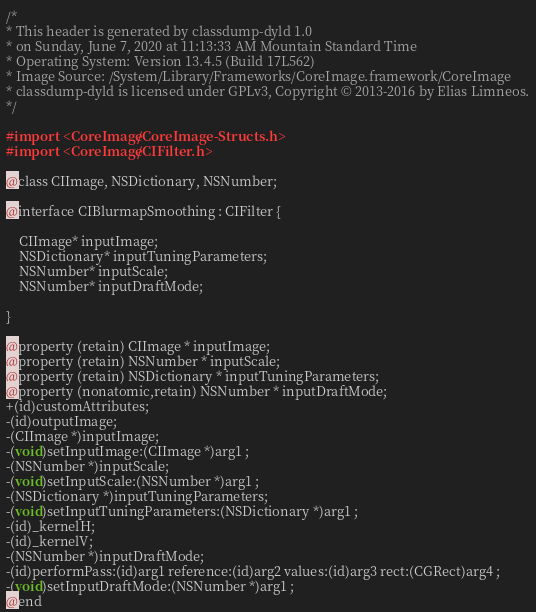Convert code to text. <code><loc_0><loc_0><loc_500><loc_500><_C_>/*
* This header is generated by classdump-dyld 1.0
* on Sunday, June 7, 2020 at 11:13:33 AM Mountain Standard Time
* Operating System: Version 13.4.5 (Build 17L562)
* Image Source: /System/Library/Frameworks/CoreImage.framework/CoreImage
* classdump-dyld is licensed under GPLv3, Copyright © 2013-2016 by Elias Limneos.
*/

#import <CoreImage/CoreImage-Structs.h>
#import <CoreImage/CIFilter.h>

@class CIImage, NSDictionary, NSNumber;

@interface CIBlurmapSmoothing : CIFilter {

	CIImage* inputImage;
	NSDictionary* inputTuningParameters;
	NSNumber* inputScale;
	NSNumber* inputDraftMode;

}

@property (retain) CIImage * inputImage; 
@property (retain) NSNumber * inputScale; 
@property (retain) NSDictionary * inputTuningParameters; 
@property (nonatomic,retain) NSNumber * inputDraftMode; 
+(id)customAttributes;
-(id)outputImage;
-(CIImage *)inputImage;
-(void)setInputImage:(CIImage *)arg1 ;
-(NSNumber *)inputScale;
-(void)setInputScale:(NSNumber *)arg1 ;
-(NSDictionary *)inputTuningParameters;
-(void)setInputTuningParameters:(NSDictionary *)arg1 ;
-(id)_kernelH;
-(id)_kernelV;
-(NSNumber *)inputDraftMode;
-(id)performPass:(id)arg1 reference:(id)arg2 values:(id)arg3 rect:(CGRect)arg4 ;
-(void)setInputDraftMode:(NSNumber *)arg1 ;
@end

</code> 